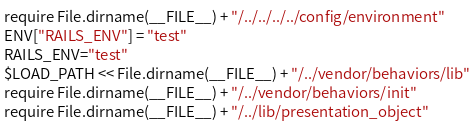Convert code to text. <code><loc_0><loc_0><loc_500><loc_500><_Ruby_>require File.dirname(__FILE__) + "/../../../../config/environment"
ENV["RAILS_ENV"] = "test"
RAILS_ENV="test"
$LOAD_PATH << File.dirname(__FILE__) + "/../vendor/behaviors/lib"
require File.dirname(__FILE__) + "/../vendor/behaviors/init"
require File.dirname(__FILE__) + "/../lib/presentation_object"</code> 